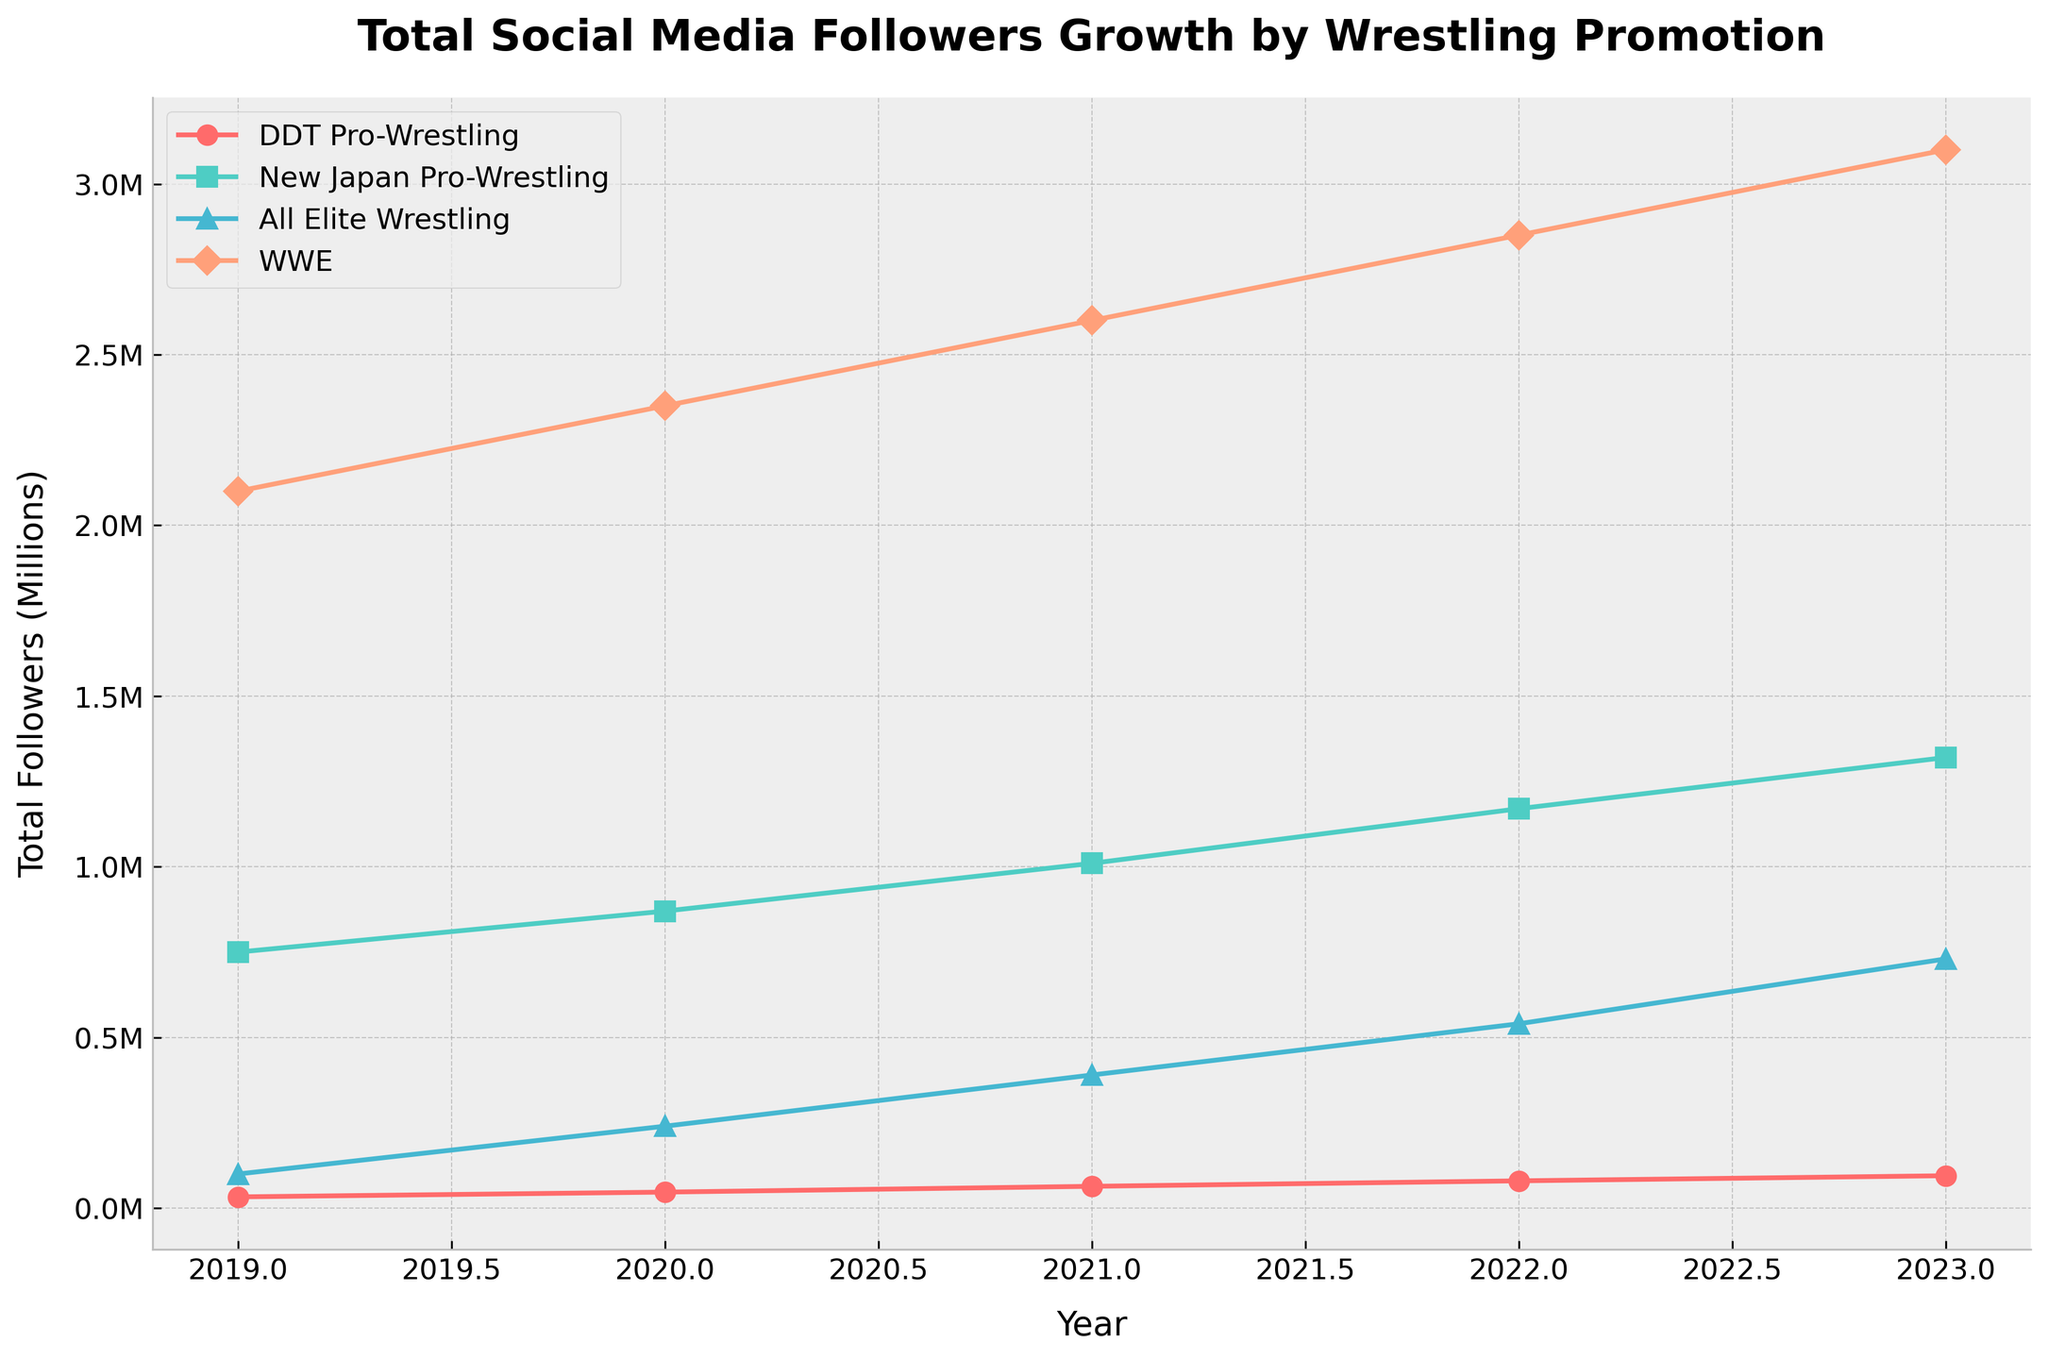What is the title of the plot? The title of the plot is usually placed at the top of the figure. In this case, it clearly mentions "Total Social Media Followers Growth by Wrestling Promotion."
Answer: Total Social Media Followers Growth by Wrestling Promotion Which wrestling promotion had the highest number of total social media followers in 2023? To find this, look at the data points for each promotion in 2023 and identify the highest one. The WWE data point is the highest as it represents 3,000,000 followers.
Answer: WWE How many promotions are compared in the plot? The number of distinct lines in the plot, each with a different color and marker, represent different promotions. There are four different promotions compared.
Answer: Four What was the approximate total number of social media followers for DDT Pro-Wrestling in 2020? Add the 2020 follower counts for Twitter, Instagram, and Facebook for DDT Pro-Wrestling: 20,000 (Twitter) + 15,000 (Instagram) + 12,000 (Facebook) = 47,000 followers.
Answer: 47,000 Which promotion showed the greatest increase in total followers from 2019 to 2023? Calculate the increase for each promotion from 2019 to 2023 and compare. WWE increased from 2,100,000 to 3,000,000, a difference of 900,000 which is the largest increase.
Answer: WWE Between 2021 and 2022, which promotion had the biggest percentage increase in total followers? Calculate the percentage increase for each promotion. For example, DDT Pro-Wrestling went from 64,000 (2021) to 80,000 (2022), an increase of 16,000 which is 25%. Check similarly for the others.
Answer: All Elite Wrestling What is the general trend of social media followers for DDT Pro-Wrestling over the years? Observe the line representing DDT Pro-Wrestling. It continually moves upward indicating a consistent growth trend from 2019 to 2023.
Answer: Increasing Compare the follower growth rate of DDT Pro-Wrestling on Twitter to that on Instagram. Look at the slopes of the lines representing DDT Pro-Wrestling’s Twitter and Instagram followers. While both are increasing, Twitter shows a sharper slope, indicating a higher growth rate.
Answer: Twitter has a higher growth rate How many millions of social media followers did New Japan Pro-Wrestling have in total across all platforms in 2023? Add up the total number of followers across Twitter, Instagram, and Facebook for New Japan Pro-Wrestling in 2023: 530,000 + 440,000 + 350,000 = 1,320,000, which is 1.32 million.
Answer: 1.32 million 